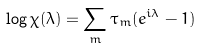Convert formula to latex. <formula><loc_0><loc_0><loc_500><loc_500>\log \chi ( \lambda ) = \sum _ { m } \tau _ { m } ( e ^ { i \lambda } - 1 )</formula> 